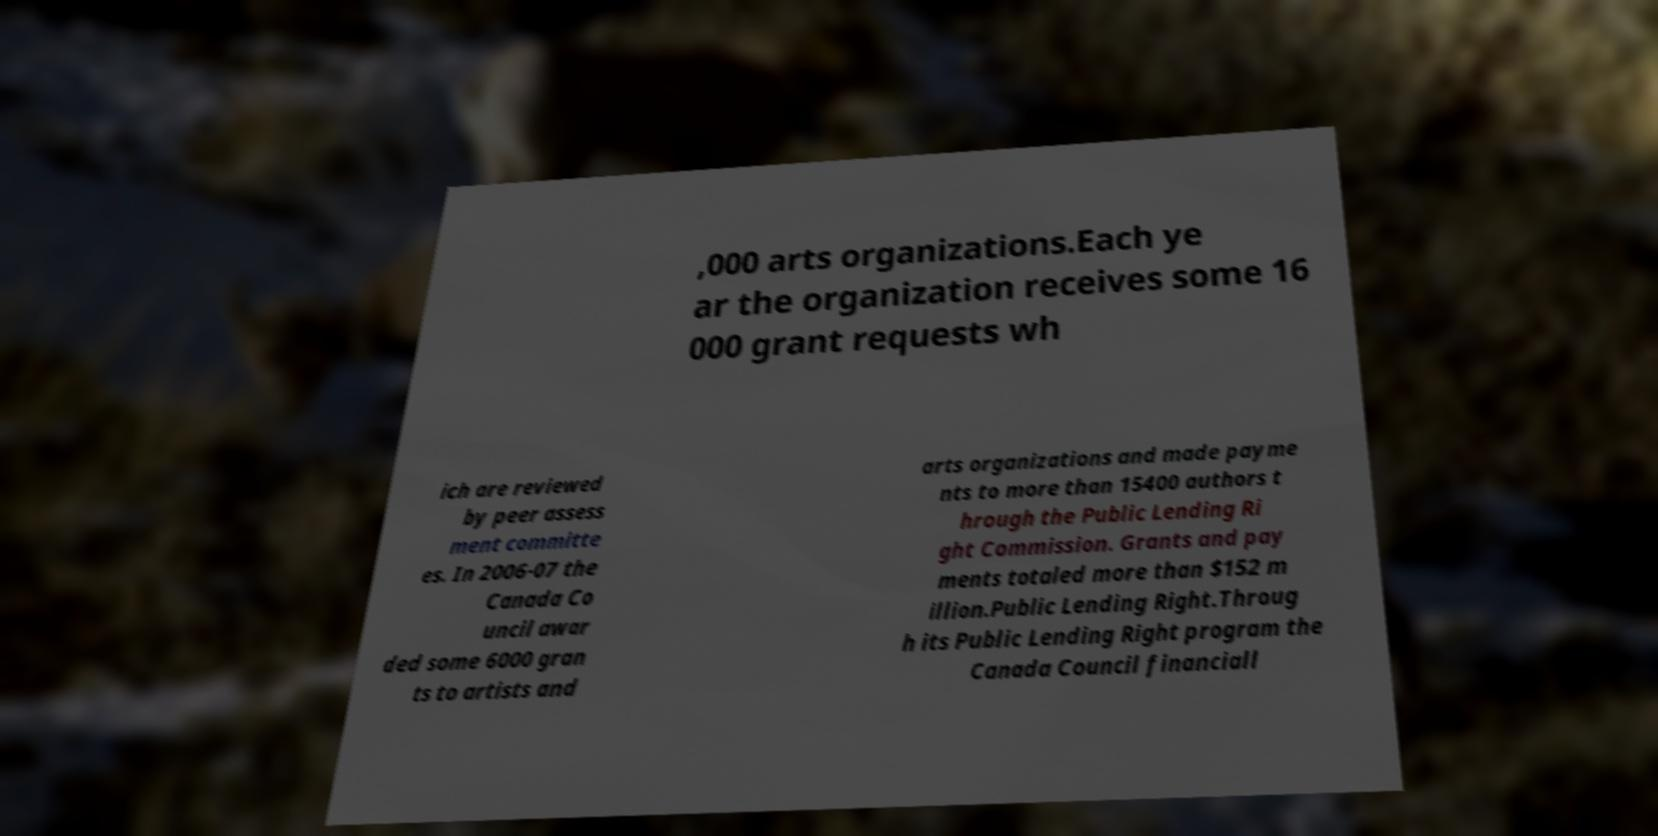Please identify and transcribe the text found in this image. ,000 arts organizations.Each ye ar the organization receives some 16 000 grant requests wh ich are reviewed by peer assess ment committe es. In 2006-07 the Canada Co uncil awar ded some 6000 gran ts to artists and arts organizations and made payme nts to more than 15400 authors t hrough the Public Lending Ri ght Commission. Grants and pay ments totaled more than $152 m illion.Public Lending Right.Throug h its Public Lending Right program the Canada Council financiall 